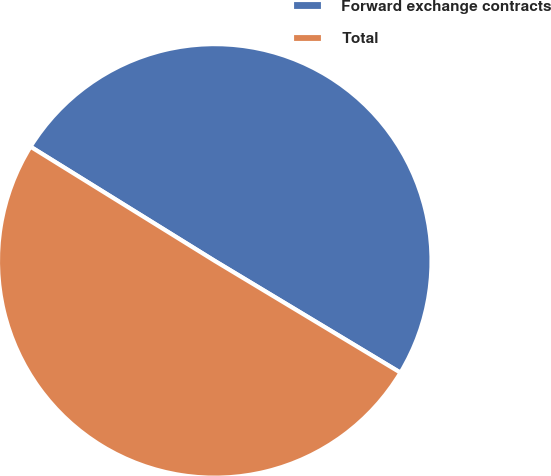<chart> <loc_0><loc_0><loc_500><loc_500><pie_chart><fcel>Forward exchange contracts<fcel>Total<nl><fcel>49.79%<fcel>50.21%<nl></chart> 